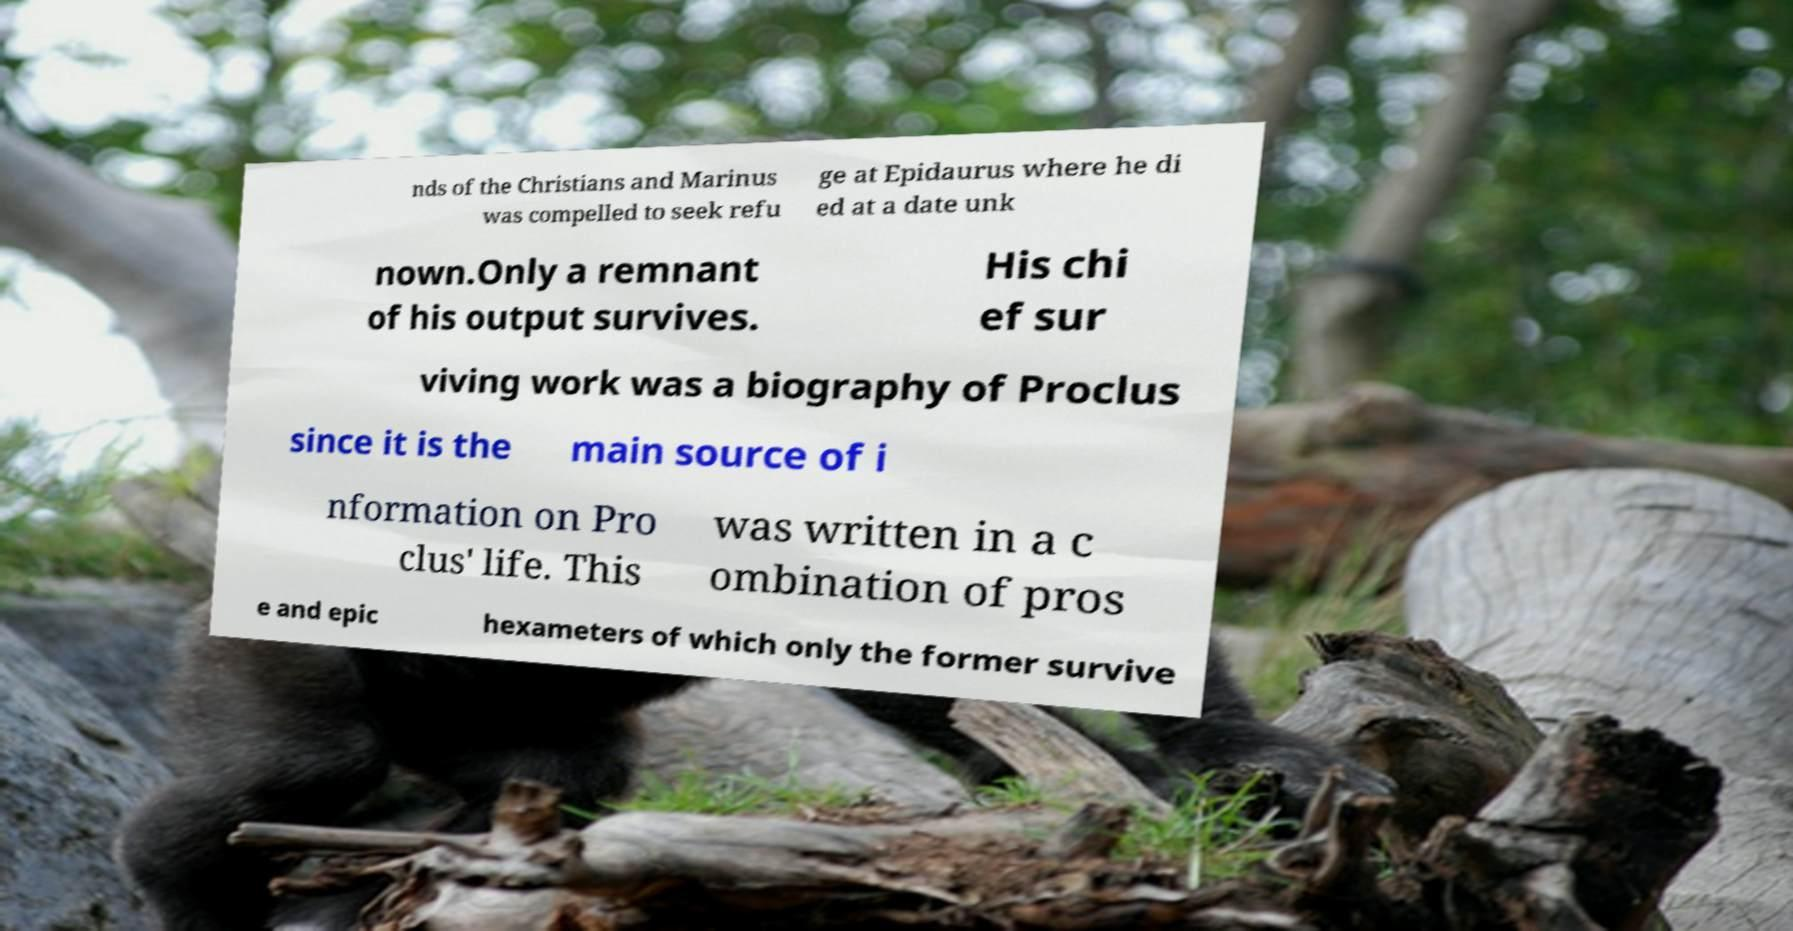Could you assist in decoding the text presented in this image and type it out clearly? nds of the Christians and Marinus was compelled to seek refu ge at Epidaurus where he di ed at a date unk nown.Only a remnant of his output survives. His chi ef sur viving work was a biography of Proclus since it is the main source of i nformation on Pro clus' life. This was written in a c ombination of pros e and epic hexameters of which only the former survive 